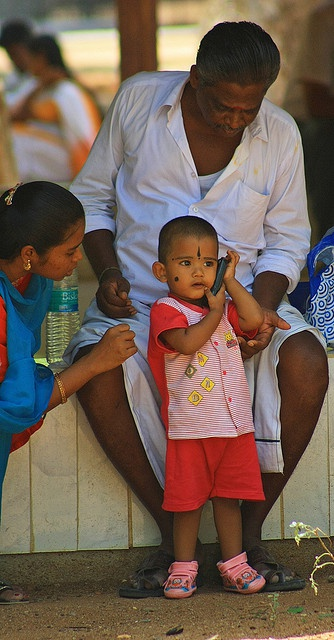Describe the objects in this image and their specific colors. I can see people in gray, darkgray, black, and maroon tones, people in gray, brown, black, and maroon tones, people in gray, black, maroon, blue, and brown tones, people in gray, darkgray, brown, and maroon tones, and people in gray, black, and darkgray tones in this image. 